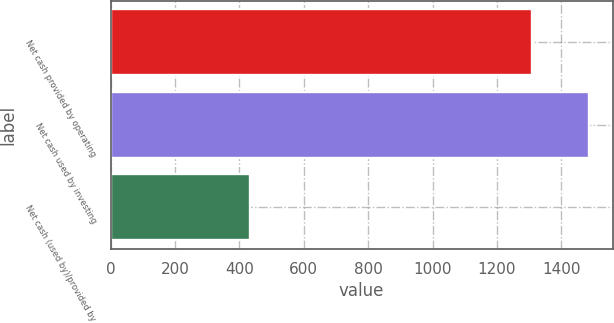Convert chart. <chart><loc_0><loc_0><loc_500><loc_500><bar_chart><fcel>Net cash provided by operating<fcel>Net cash used by investing<fcel>Net cash (used by)/provided by<nl><fcel>1309<fcel>1485<fcel>432<nl></chart> 